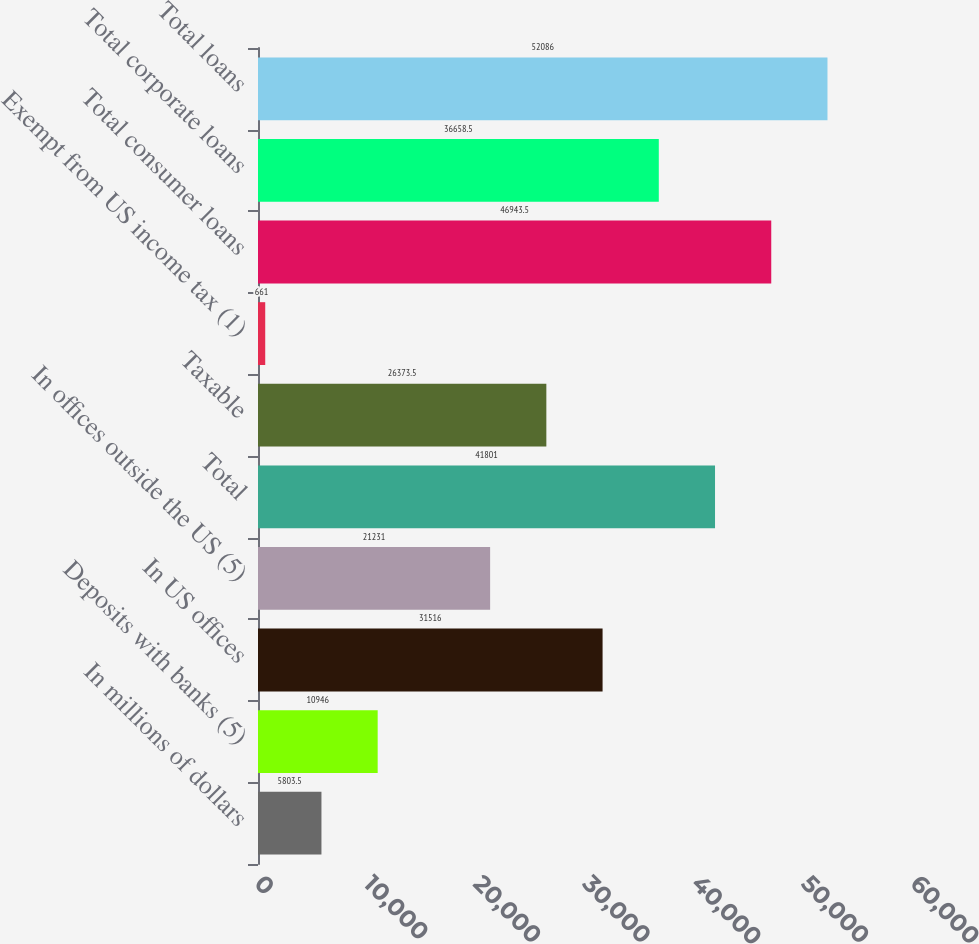<chart> <loc_0><loc_0><loc_500><loc_500><bar_chart><fcel>In millions of dollars<fcel>Deposits with banks (5)<fcel>In US offices<fcel>In offices outside the US (5)<fcel>Total<fcel>Taxable<fcel>Exempt from US income tax (1)<fcel>Total consumer loans<fcel>Total corporate loans<fcel>Total loans<nl><fcel>5803.5<fcel>10946<fcel>31516<fcel>21231<fcel>41801<fcel>26373.5<fcel>661<fcel>46943.5<fcel>36658.5<fcel>52086<nl></chart> 